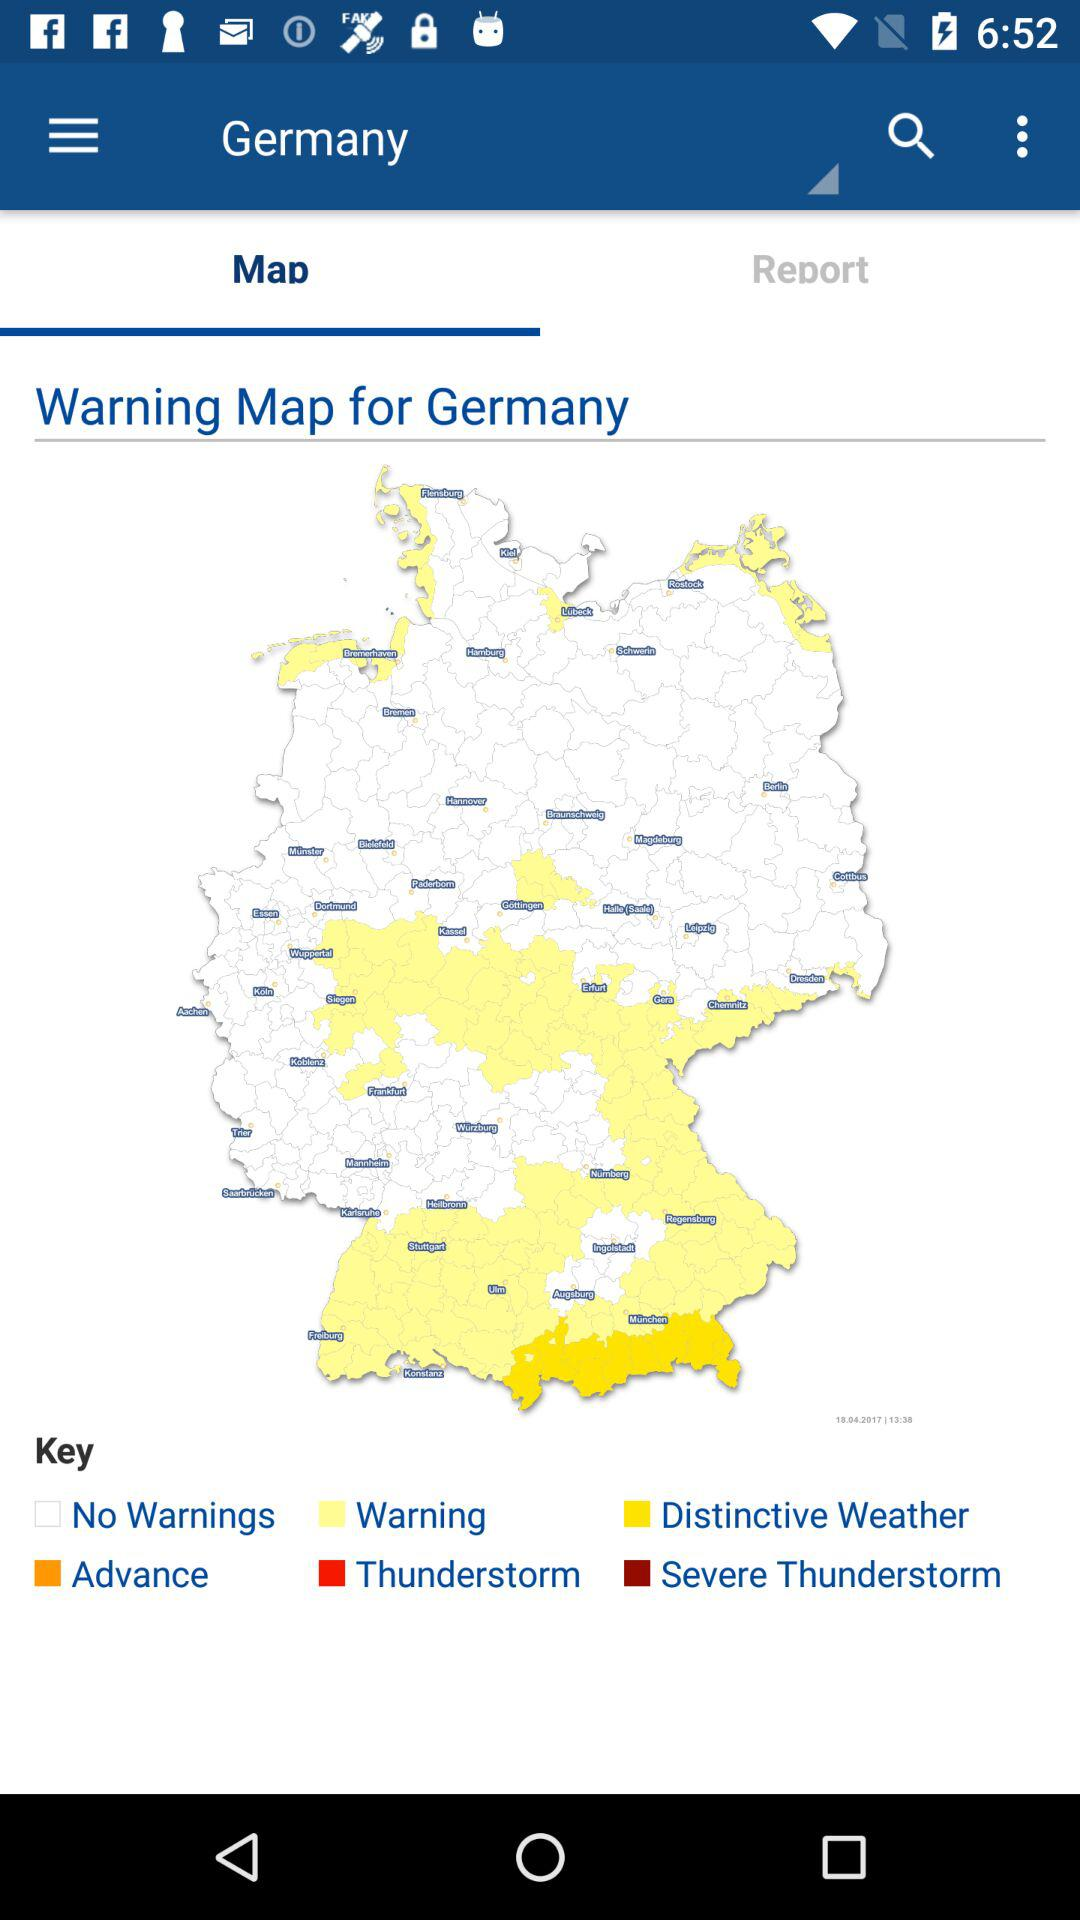Which tab has been selected? The tab "Map" has been selected. 